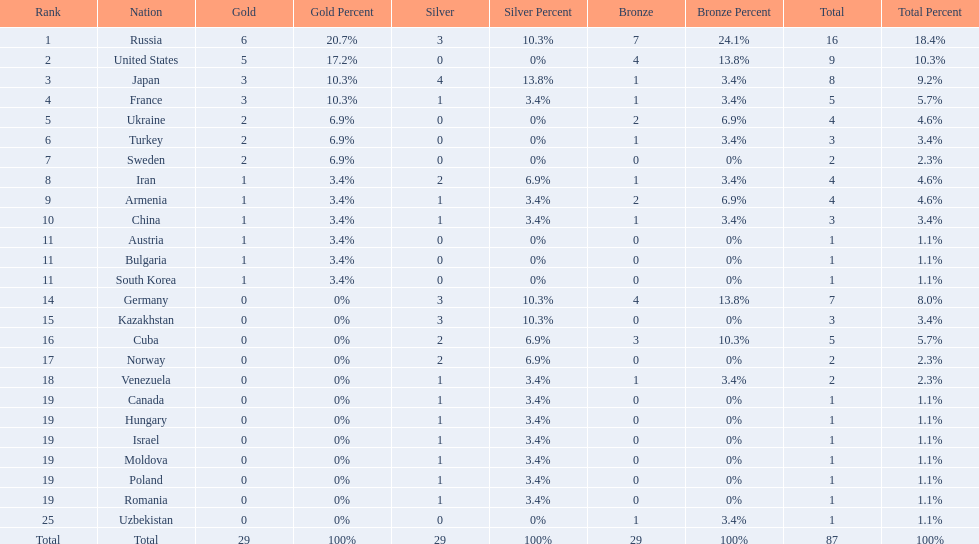Which country won only one medal, a bronze medal? Uzbekistan. 